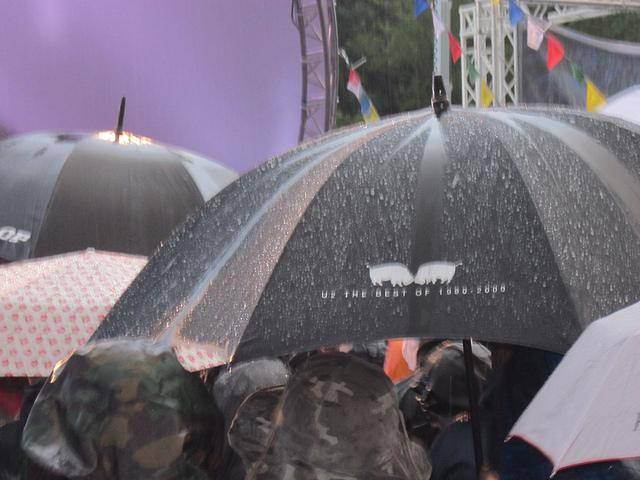What is happening here?

Choices:
A) umbrella sale
B) going home
C) surprise rain
D) u2 concert u2 concert 